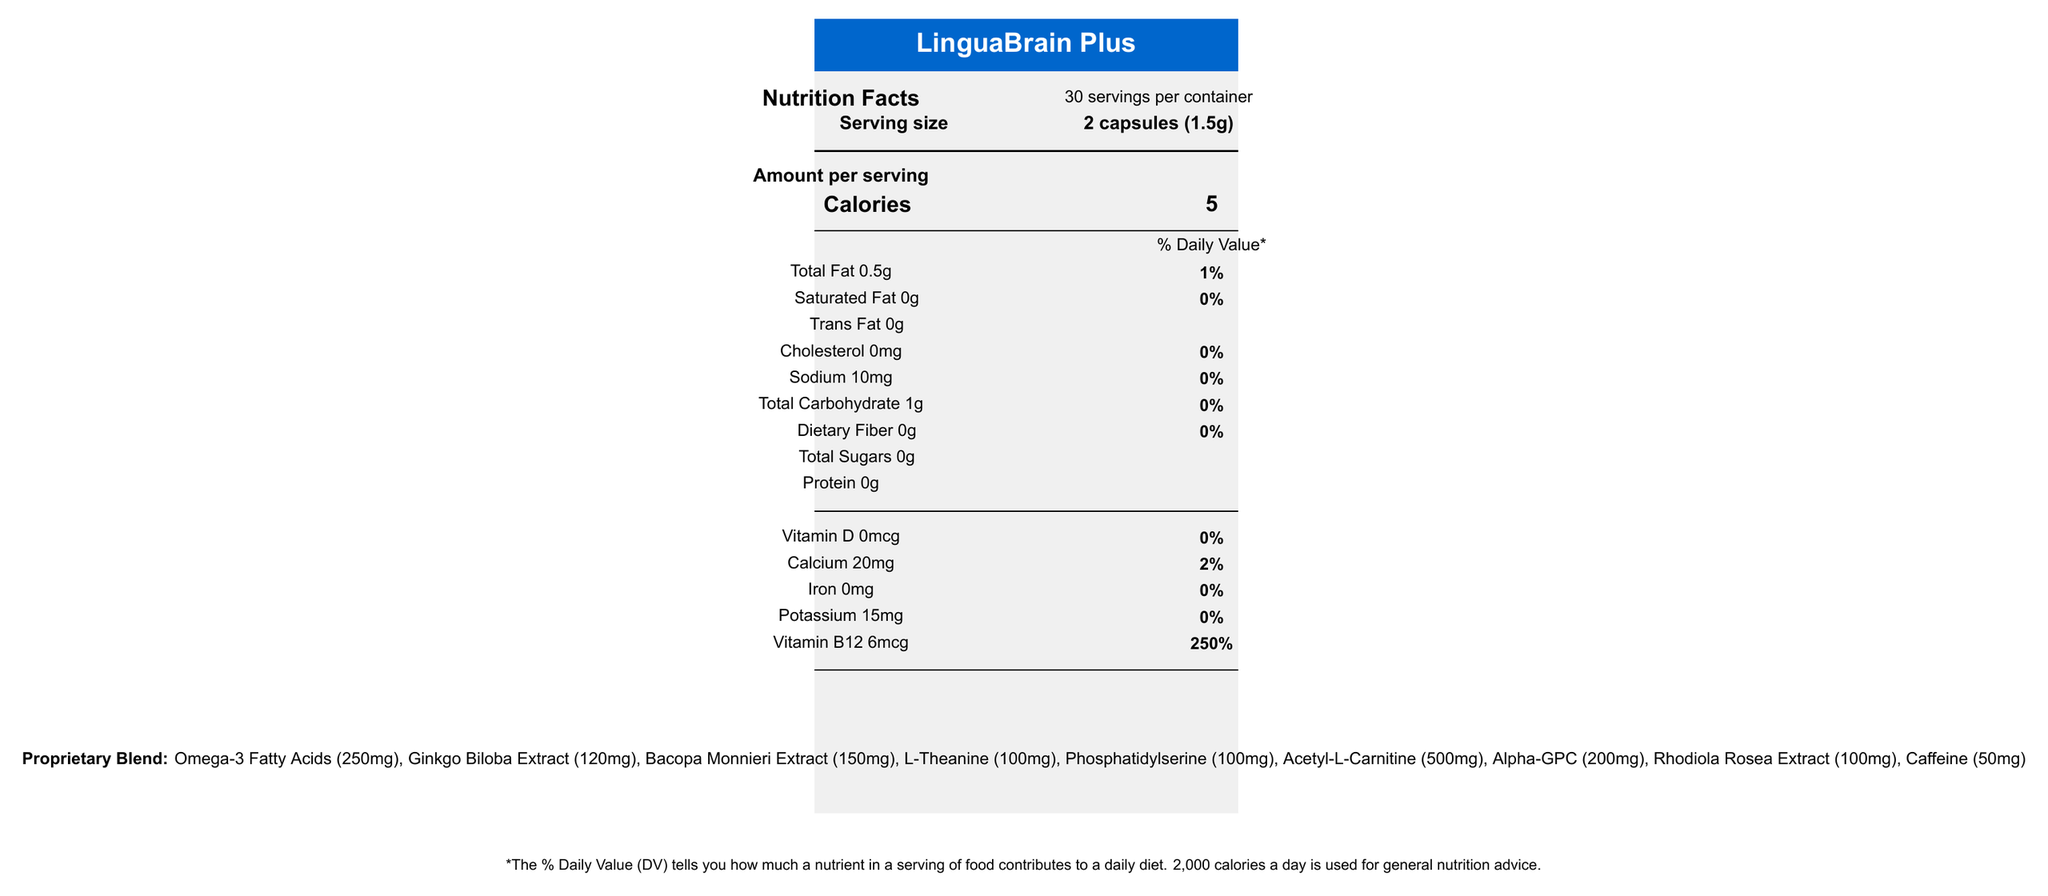what is the product name? The product name is given at the top of the document within a blue rectangle alongside the white text "LinguaBrain Plus".
Answer: LinguaBrain Plus how many calories are in a serving? The number of calories per serving is listed under "Amount per serving" and "Calories".
Answer: 5 what is the serving size? The serving size is specified as "2 capsules (1.5g)" under the "Serving size" heading.
Answer: 2 capsules (1.5g) how much vitamin B12 is in a serving? Vitamin B12 content per serving is shown under the list of vitamins and minerals as "Vitamin B12 6mcg".
Answer: 6mcg how much sodium does one serving contain? The sodium content per serving is listed as "Sodium 10mg".
Answer: 10mg which ingredient is present in the largest amount in the proprietary blend? A. Ginkgo Biloba Extract B. Acetyl-L-Carnitine C. Alpha-GPC D. Rhodiola Rosea Extract The proprietary blend lists ingredients with their respective amounts, where Acetyl-L-Carnitine (500mg) is the highest.
Answer: B. Acetyl-L-Carnitine which of the following claims is NOT made about LinguaBrain Plus? A. Supports cognitive function and language processing B. Reduces risk of heart disease C. Enhances focus and mental clarity during research tasks D. Promotes memory retention for linguistic data analysis The document lists several marketing claims, but reducing heart disease risk is not one of them.
Answer: B. Reduces risk of heart disease does LinguaBrain Plus contain any protein? Protein is listed as "0g" under the nutritional information.
Answer: No is this product suitable for someone who is allergic to soy? The "allergen info" section states that the product contains soy (phosphatidylserine).
Answer: No is LinguaBrain Plus recommended for pregnant women? The warnings mention consulting a healthcare professional before use if you are pregnant.
Answer: Consult a healthcare professional summarize the main information provided in the document. The summary includes key features like the product's name, purpose, nutritional details, ingredient amounts, recommended usage, warnings, and marketing points.
Answer: The document describes the "LinguaBrain Plus" supplement, detailing its nutritional facts, ingredients, and proprietary blend. It highlights its intended use for cognitive function and memory support, especially for linguistic researchers. Directions for use, allergens, warnings, and marketing claims are also specified. what is the exact amount of phosphatidylserine in a serving? According to the proprietary blend information, there are 100mg of Phosphatidylserine per serving.
Answer: 100mg how many other ingredients are listed for LinguaBrain Plus? A. Two B. Three C. Four D. Five The document lists four other ingredients: Microcrystalline cellulose, Vegetable capsule (hydroxypropyl methylcellulose), Silicon dioxide, and Magnesium stearate.
Answer: C. Four does LinguaBrain Plus contain any sugar? The document states "Total Sugars 0g" under the nutritional information.
Answer: No what are the storage recommendations for LinguaBrain Plus? The warnings include a note to "Store in a cool, dry place".
Answer: Store in a cool, dry place how many mg of omega-3 fatty acids does LinguaBrain Plus contain? The proprietary blend section indicates that there are 250mg of Omega-3 Fatty Acids per serving.
Answer: 250mg where is the document generated from? The document does not provide any information about its generation process or source of creation.
Answer: Not enough information 